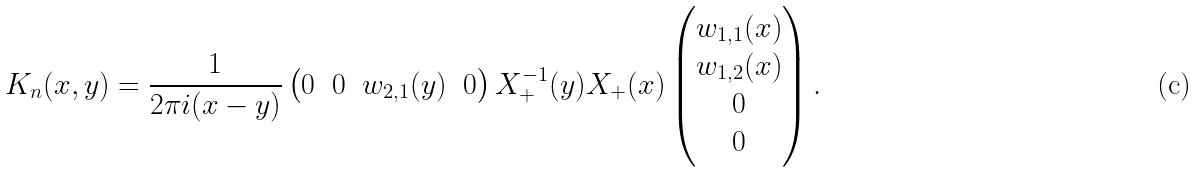Convert formula to latex. <formula><loc_0><loc_0><loc_500><loc_500>K _ { n } ( x , y ) = \frac { 1 } { 2 \pi i ( x - y ) } \begin{pmatrix} 0 & 0 & w _ { 2 , 1 } ( y ) & 0 \end{pmatrix} X _ { + } ^ { - 1 } ( y ) X _ { + } ( x ) \begin{pmatrix} w _ { 1 , 1 } ( x ) \\ w _ { 1 , 2 } ( x ) \\ 0 \\ 0 \end{pmatrix} .</formula> 